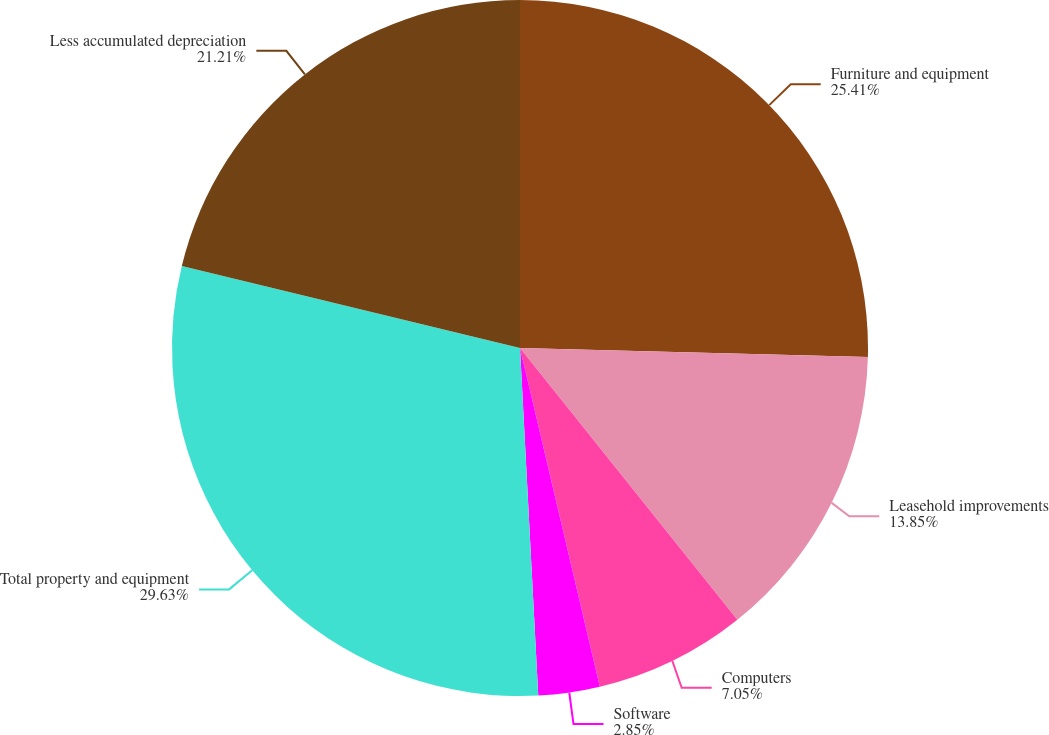Convert chart. <chart><loc_0><loc_0><loc_500><loc_500><pie_chart><fcel>Furniture and equipment<fcel>Leasehold improvements<fcel>Computers<fcel>Software<fcel>Total property and equipment<fcel>Less accumulated depreciation<nl><fcel>25.41%<fcel>13.85%<fcel>7.05%<fcel>2.85%<fcel>29.62%<fcel>21.21%<nl></chart> 